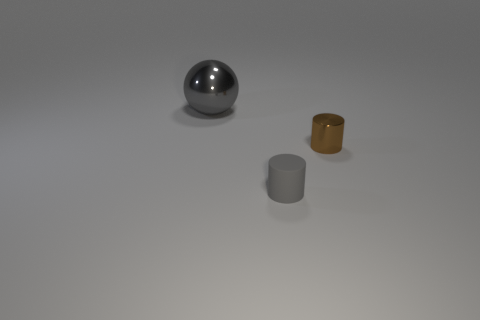How many other things are made of the same material as the brown thing?
Offer a very short reply. 1. Do the shiny object in front of the large metal ball and the cylinder in front of the brown shiny cylinder have the same color?
Your answer should be very brief. No. What shape is the thing that is behind the cylinder that is behind the gray rubber cylinder?
Provide a succinct answer. Sphere. What number of other things are the same color as the small rubber cylinder?
Provide a succinct answer. 1. Do the gray thing right of the big gray ball and the cylinder that is behind the tiny gray cylinder have the same material?
Your answer should be very brief. No. There is a gray thing to the right of the gray metallic object; what size is it?
Offer a terse response. Small. There is another small thing that is the same shape as the brown shiny object; what is it made of?
Your answer should be compact. Rubber. Is there anything else that is the same size as the brown metal thing?
Your answer should be compact. Yes. What is the shape of the gray object in front of the big gray metal sphere?
Offer a very short reply. Cylinder. How many brown shiny things have the same shape as the tiny gray object?
Your answer should be compact. 1. 